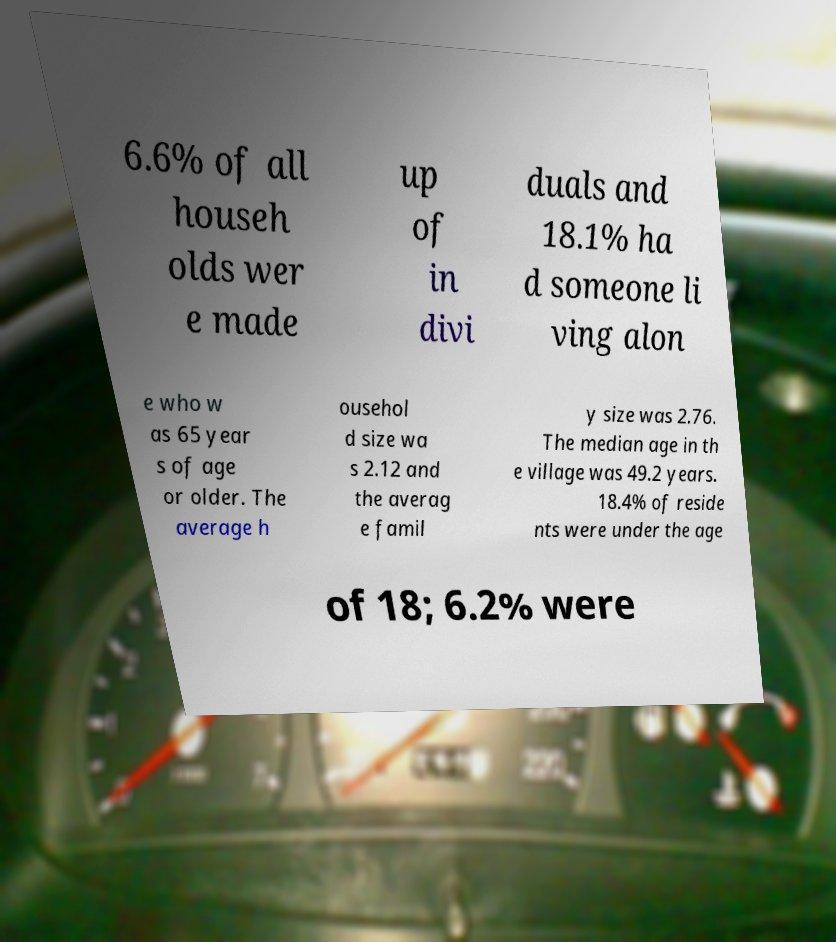Please identify and transcribe the text found in this image. 6.6% of all househ olds wer e made up of in divi duals and 18.1% ha d someone li ving alon e who w as 65 year s of age or older. The average h ousehol d size wa s 2.12 and the averag e famil y size was 2.76. The median age in th e village was 49.2 years. 18.4% of reside nts were under the age of 18; 6.2% were 